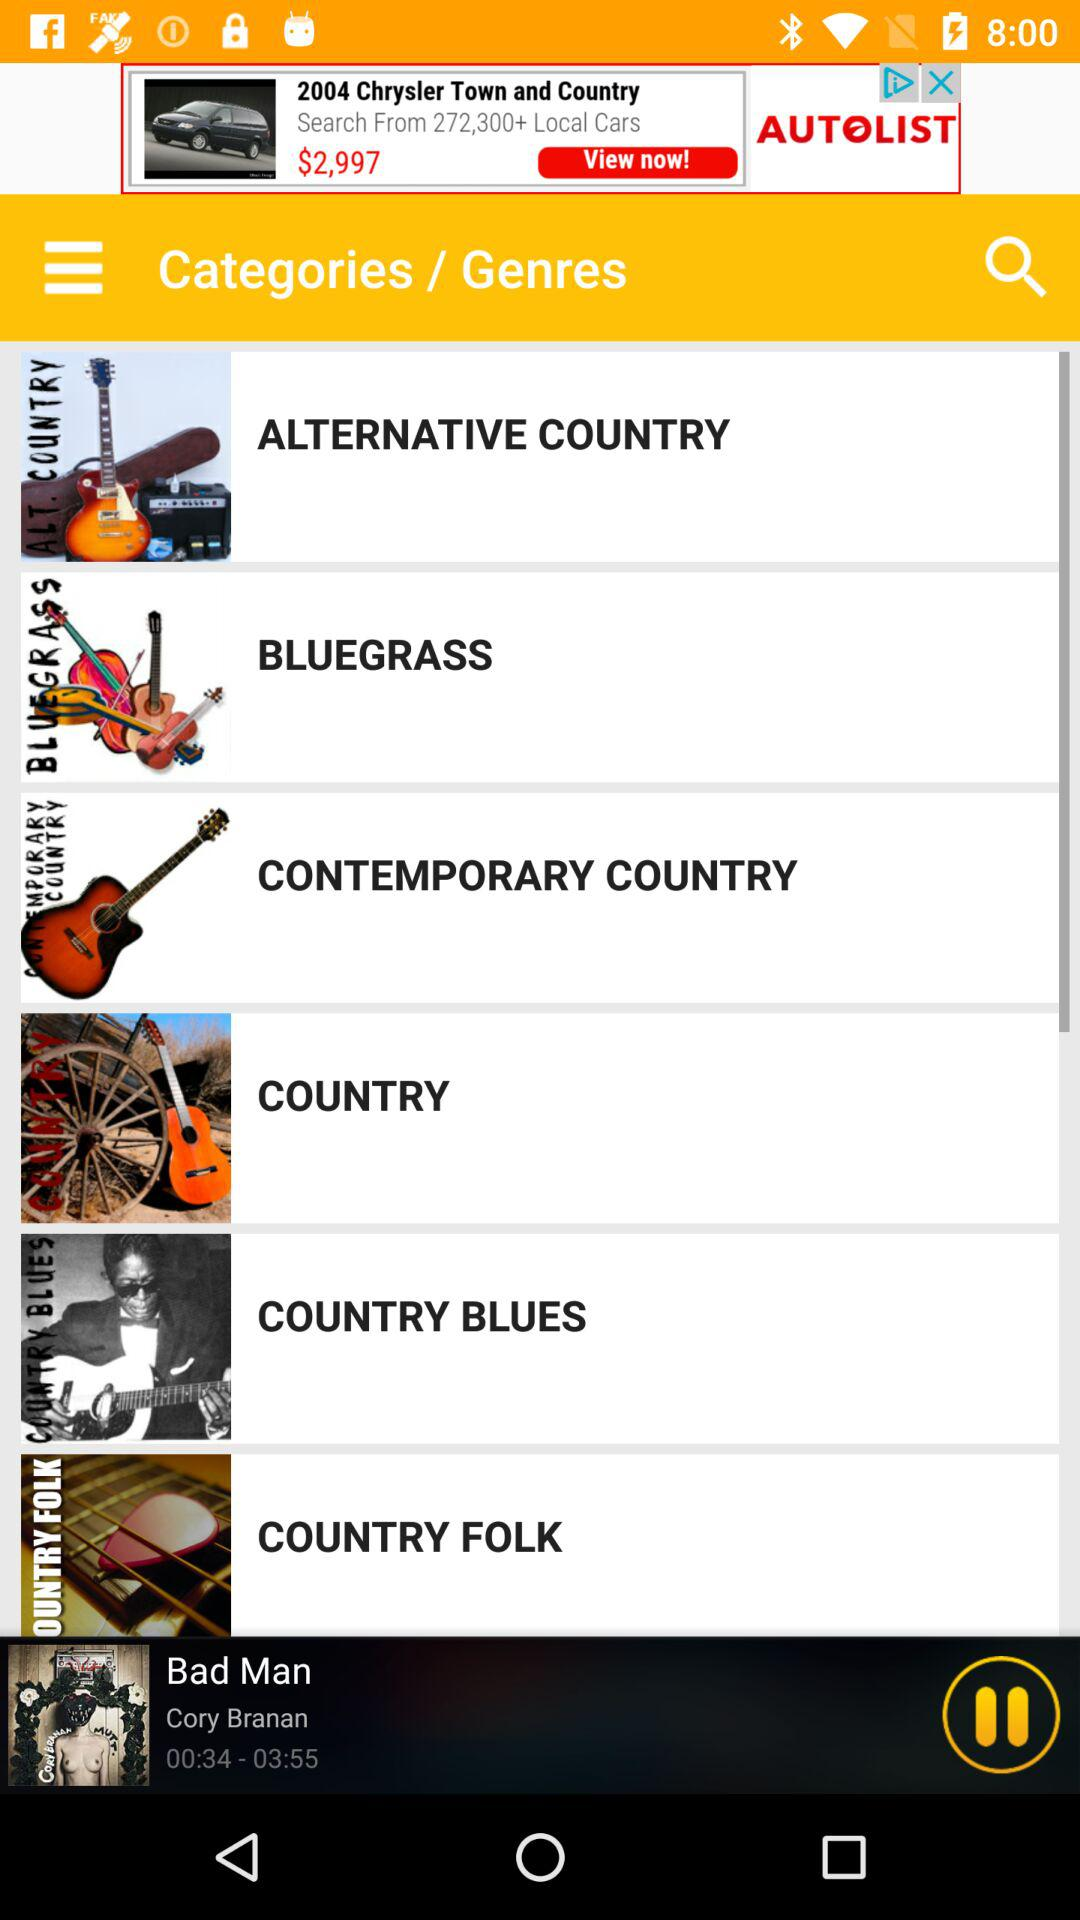For how long has the song been played? The song has been played for 34 seconds. 